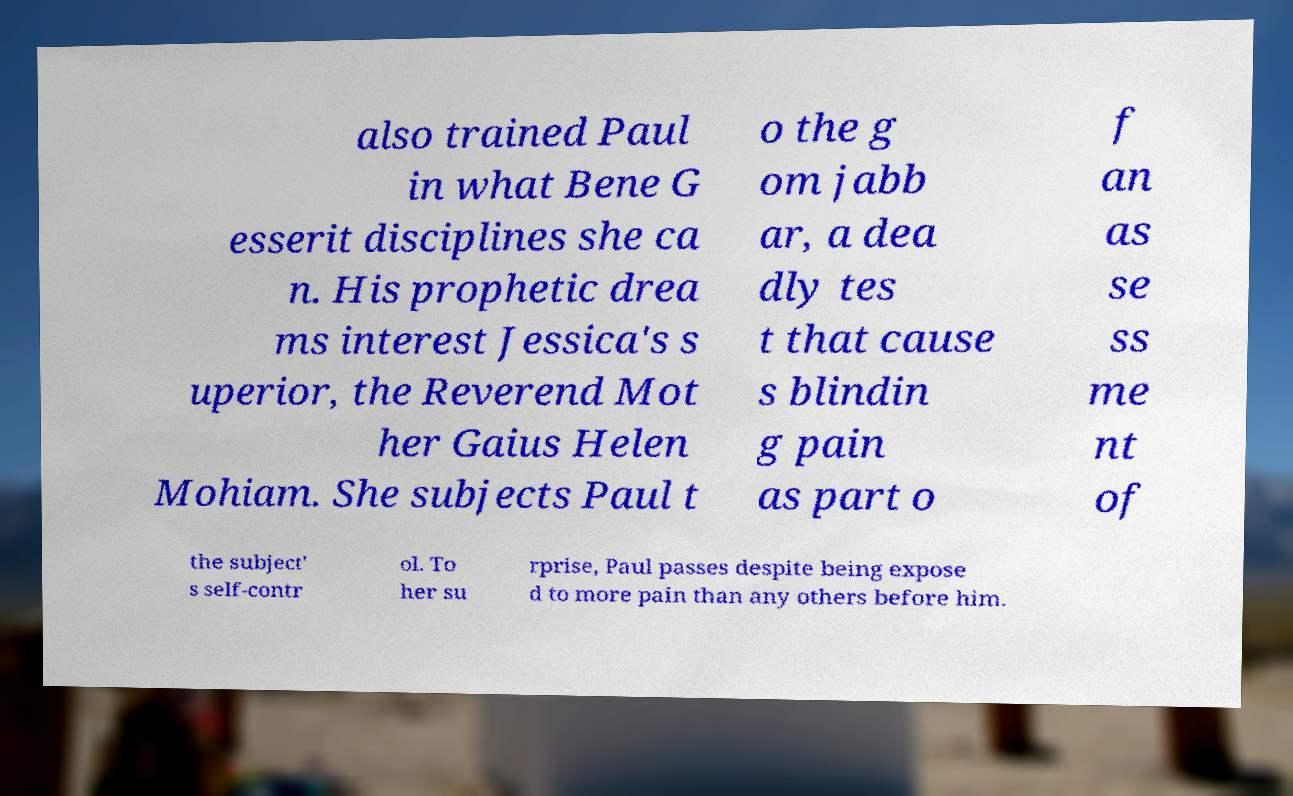Could you extract and type out the text from this image? also trained Paul in what Bene G esserit disciplines she ca n. His prophetic drea ms interest Jessica's s uperior, the Reverend Mot her Gaius Helen Mohiam. She subjects Paul t o the g om jabb ar, a dea dly tes t that cause s blindin g pain as part o f an as se ss me nt of the subject' s self-contr ol. To her su rprise, Paul passes despite being expose d to more pain than any others before him. 